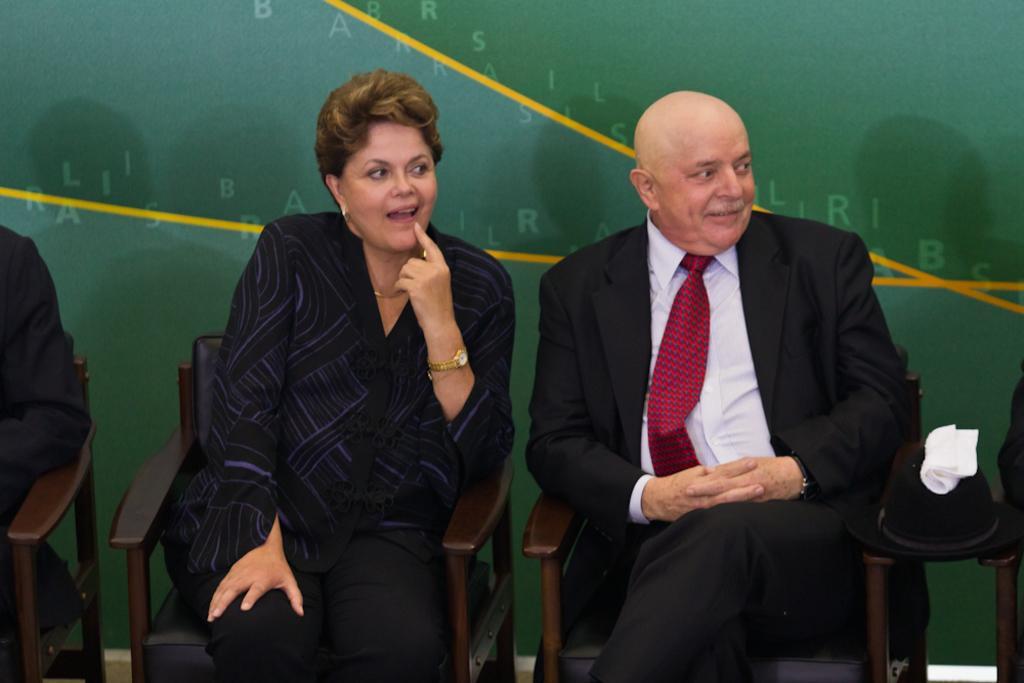Can you describe this image briefly? In the image we can see there are people sitting on the chairs and there is helmet and kerchief kept on the table. 